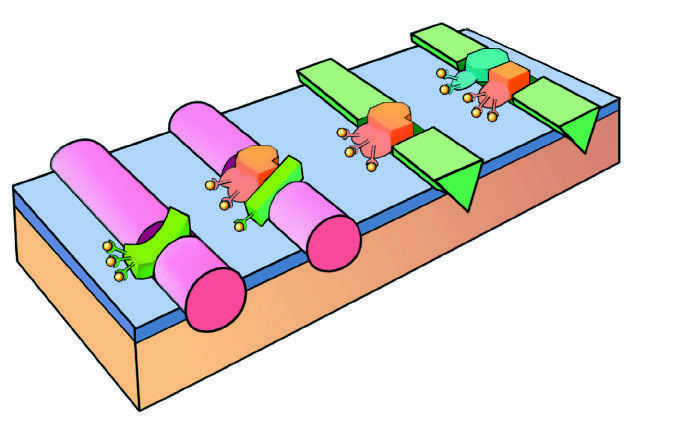does atrophy of the brain consist of a protease assembled on a platelet phospholipid surface?
Answer the question using a single word or phrase. No 